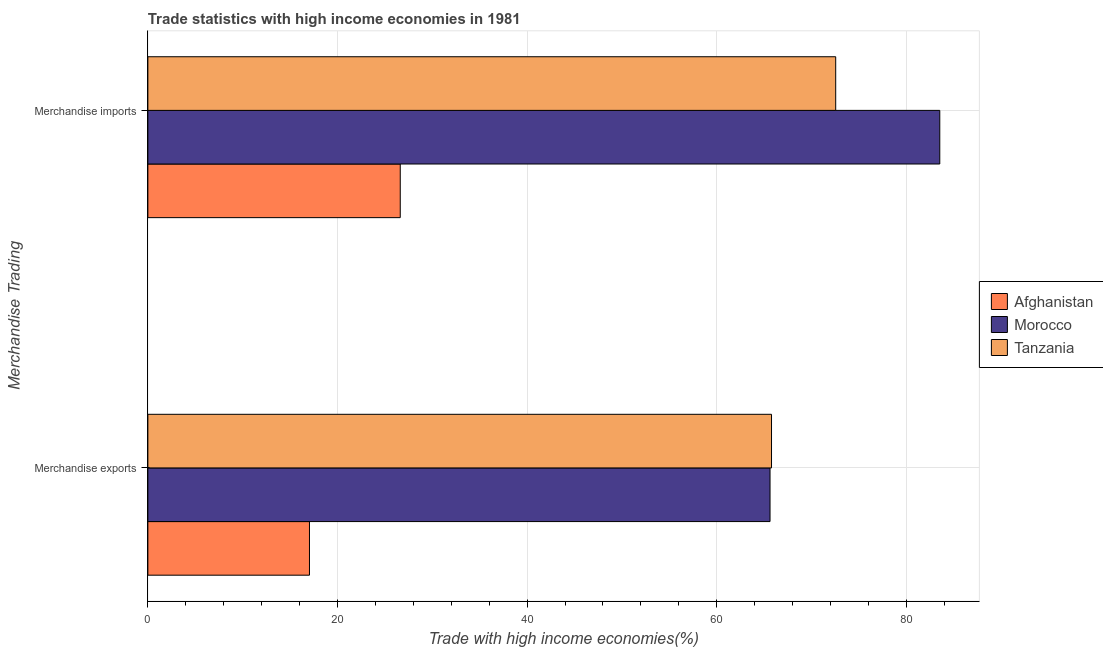How many groups of bars are there?
Provide a short and direct response. 2. Are the number of bars on each tick of the Y-axis equal?
Your response must be concise. Yes. How many bars are there on the 2nd tick from the top?
Give a very brief answer. 3. What is the label of the 2nd group of bars from the top?
Offer a terse response. Merchandise exports. What is the merchandise imports in Morocco?
Provide a succinct answer. 83.53. Across all countries, what is the maximum merchandise imports?
Your response must be concise. 83.53. Across all countries, what is the minimum merchandise exports?
Ensure brevity in your answer.  17.04. In which country was the merchandise imports maximum?
Your response must be concise. Morocco. In which country was the merchandise exports minimum?
Your response must be concise. Afghanistan. What is the total merchandise exports in the graph?
Your response must be concise. 148.44. What is the difference between the merchandise imports in Morocco and that in Tanzania?
Your answer should be compact. 10.98. What is the difference between the merchandise exports in Morocco and the merchandise imports in Tanzania?
Your answer should be very brief. -6.93. What is the average merchandise imports per country?
Provide a succinct answer. 60.9. What is the difference between the merchandise exports and merchandise imports in Afghanistan?
Offer a very short reply. -9.58. In how many countries, is the merchandise imports greater than 52 %?
Offer a terse response. 2. What is the ratio of the merchandise imports in Afghanistan to that in Tanzania?
Your answer should be very brief. 0.37. In how many countries, is the merchandise exports greater than the average merchandise exports taken over all countries?
Provide a short and direct response. 2. What does the 1st bar from the top in Merchandise exports represents?
Keep it short and to the point. Tanzania. What does the 2nd bar from the bottom in Merchandise imports represents?
Make the answer very short. Morocco. How many bars are there?
Your response must be concise. 6. How many countries are there in the graph?
Keep it short and to the point. 3. What is the difference between two consecutive major ticks on the X-axis?
Provide a succinct answer. 20. Does the graph contain grids?
Provide a short and direct response. Yes. How are the legend labels stacked?
Give a very brief answer. Vertical. What is the title of the graph?
Provide a succinct answer. Trade statistics with high income economies in 1981. Does "Argentina" appear as one of the legend labels in the graph?
Offer a terse response. No. What is the label or title of the X-axis?
Your answer should be very brief. Trade with high income economies(%). What is the label or title of the Y-axis?
Provide a short and direct response. Merchandise Trading. What is the Trade with high income economies(%) of Afghanistan in Merchandise exports?
Give a very brief answer. 17.04. What is the Trade with high income economies(%) of Morocco in Merchandise exports?
Your answer should be very brief. 65.62. What is the Trade with high income economies(%) in Tanzania in Merchandise exports?
Your response must be concise. 65.78. What is the Trade with high income economies(%) of Afghanistan in Merchandise imports?
Your response must be concise. 26.62. What is the Trade with high income economies(%) of Morocco in Merchandise imports?
Your answer should be very brief. 83.53. What is the Trade with high income economies(%) of Tanzania in Merchandise imports?
Your answer should be very brief. 72.55. Across all Merchandise Trading, what is the maximum Trade with high income economies(%) in Afghanistan?
Keep it short and to the point. 26.62. Across all Merchandise Trading, what is the maximum Trade with high income economies(%) in Morocco?
Your answer should be very brief. 83.53. Across all Merchandise Trading, what is the maximum Trade with high income economies(%) in Tanzania?
Ensure brevity in your answer.  72.55. Across all Merchandise Trading, what is the minimum Trade with high income economies(%) in Afghanistan?
Offer a terse response. 17.04. Across all Merchandise Trading, what is the minimum Trade with high income economies(%) in Morocco?
Ensure brevity in your answer.  65.62. Across all Merchandise Trading, what is the minimum Trade with high income economies(%) of Tanzania?
Your response must be concise. 65.78. What is the total Trade with high income economies(%) of Afghanistan in the graph?
Your response must be concise. 43.66. What is the total Trade with high income economies(%) in Morocco in the graph?
Offer a very short reply. 149.15. What is the total Trade with high income economies(%) of Tanzania in the graph?
Offer a terse response. 138.33. What is the difference between the Trade with high income economies(%) in Afghanistan in Merchandise exports and that in Merchandise imports?
Give a very brief answer. -9.58. What is the difference between the Trade with high income economies(%) in Morocco in Merchandise exports and that in Merchandise imports?
Provide a succinct answer. -17.91. What is the difference between the Trade with high income economies(%) in Tanzania in Merchandise exports and that in Merchandise imports?
Ensure brevity in your answer.  -6.77. What is the difference between the Trade with high income economies(%) of Afghanistan in Merchandise exports and the Trade with high income economies(%) of Morocco in Merchandise imports?
Give a very brief answer. -66.48. What is the difference between the Trade with high income economies(%) in Afghanistan in Merchandise exports and the Trade with high income economies(%) in Tanzania in Merchandise imports?
Your response must be concise. -55.51. What is the difference between the Trade with high income economies(%) in Morocco in Merchandise exports and the Trade with high income economies(%) in Tanzania in Merchandise imports?
Provide a short and direct response. -6.93. What is the average Trade with high income economies(%) in Afghanistan per Merchandise Trading?
Keep it short and to the point. 21.83. What is the average Trade with high income economies(%) of Morocco per Merchandise Trading?
Ensure brevity in your answer.  74.57. What is the average Trade with high income economies(%) in Tanzania per Merchandise Trading?
Your response must be concise. 69.16. What is the difference between the Trade with high income economies(%) of Afghanistan and Trade with high income economies(%) of Morocco in Merchandise exports?
Ensure brevity in your answer.  -48.58. What is the difference between the Trade with high income economies(%) in Afghanistan and Trade with high income economies(%) in Tanzania in Merchandise exports?
Offer a terse response. -48.74. What is the difference between the Trade with high income economies(%) in Morocco and Trade with high income economies(%) in Tanzania in Merchandise exports?
Keep it short and to the point. -0.16. What is the difference between the Trade with high income economies(%) of Afghanistan and Trade with high income economies(%) of Morocco in Merchandise imports?
Offer a very short reply. -56.91. What is the difference between the Trade with high income economies(%) of Afghanistan and Trade with high income economies(%) of Tanzania in Merchandise imports?
Offer a terse response. -45.93. What is the difference between the Trade with high income economies(%) in Morocco and Trade with high income economies(%) in Tanzania in Merchandise imports?
Keep it short and to the point. 10.98. What is the ratio of the Trade with high income economies(%) of Afghanistan in Merchandise exports to that in Merchandise imports?
Provide a succinct answer. 0.64. What is the ratio of the Trade with high income economies(%) in Morocco in Merchandise exports to that in Merchandise imports?
Make the answer very short. 0.79. What is the ratio of the Trade with high income economies(%) in Tanzania in Merchandise exports to that in Merchandise imports?
Your response must be concise. 0.91. What is the difference between the highest and the second highest Trade with high income economies(%) in Afghanistan?
Offer a terse response. 9.58. What is the difference between the highest and the second highest Trade with high income economies(%) of Morocco?
Keep it short and to the point. 17.91. What is the difference between the highest and the second highest Trade with high income economies(%) in Tanzania?
Provide a short and direct response. 6.77. What is the difference between the highest and the lowest Trade with high income economies(%) in Afghanistan?
Offer a very short reply. 9.58. What is the difference between the highest and the lowest Trade with high income economies(%) in Morocco?
Provide a succinct answer. 17.91. What is the difference between the highest and the lowest Trade with high income economies(%) in Tanzania?
Provide a short and direct response. 6.77. 